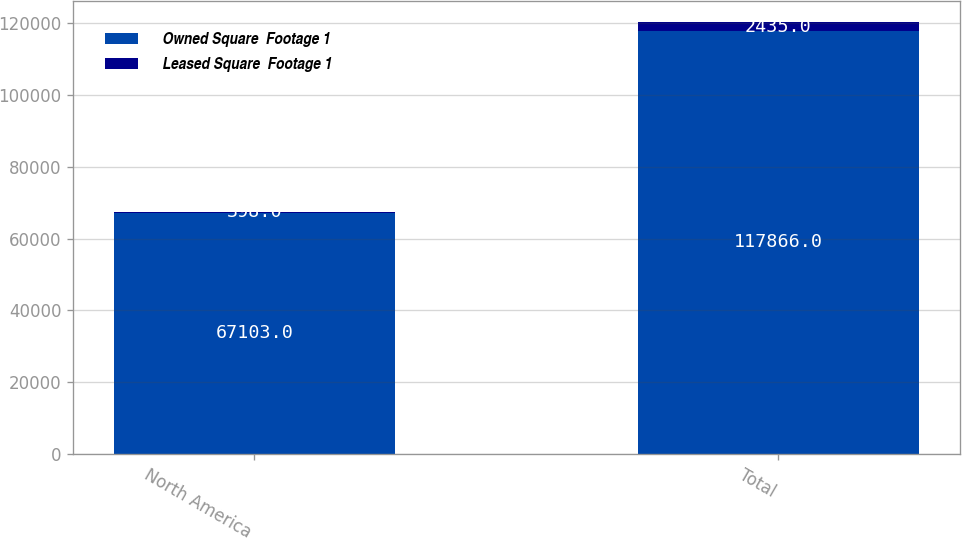Convert chart to OTSL. <chart><loc_0><loc_0><loc_500><loc_500><stacked_bar_chart><ecel><fcel>North America<fcel>Total<nl><fcel>Owned Square  Footage 1<fcel>67103<fcel>117866<nl><fcel>Leased Square  Footage 1<fcel>398<fcel>2435<nl></chart> 